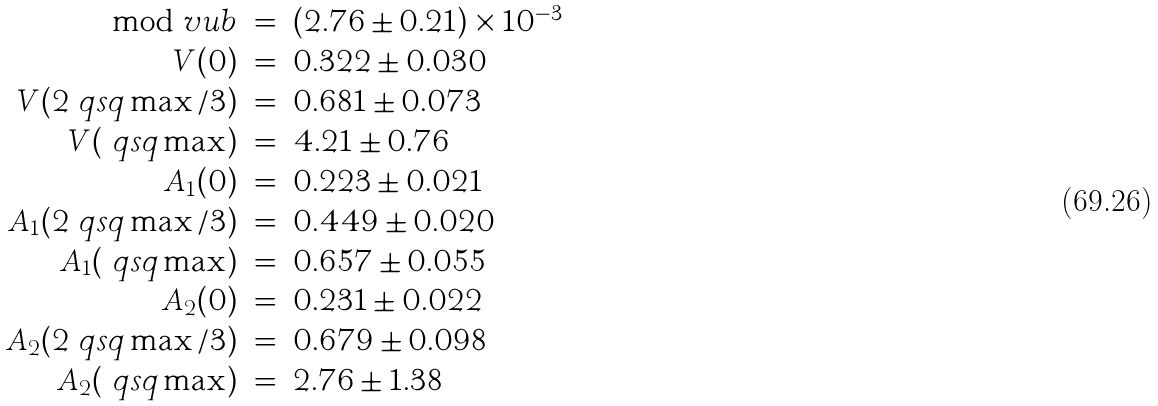<formula> <loc_0><loc_0><loc_500><loc_500>\begin{array} { r c l } \mod v u b & = & \left ( 2 . 7 6 \pm 0 . 2 1 \right ) \times 1 0 ^ { - 3 } \\ V ( 0 ) & = & 0 . 3 2 2 \pm 0 . 0 3 0 \\ V ( 2 \ q s q \max / 3 ) & = & 0 . 6 8 1 \pm 0 . 0 7 3 \\ V ( \ q s q \max ) & = & 4 . 2 1 \pm 0 . 7 6 \\ A _ { 1 } ( 0 ) & = & 0 . 2 2 3 \pm 0 . 0 2 1 \\ A _ { 1 } ( 2 \ q s q \max / 3 ) & = & 0 . 4 4 9 \pm 0 . 0 2 0 \\ A _ { 1 } ( \ q s q \max ) & = & 0 . 6 5 7 \pm 0 . 0 5 5 \\ A _ { 2 } ( 0 ) & = & 0 . 2 3 1 \pm 0 . 0 2 2 \\ A _ { 2 } ( 2 \ q s q \max / 3 ) & = & 0 . 6 7 9 \pm 0 . 0 9 8 \\ A _ { 2 } ( \ q s q \max ) & = & 2 . 7 6 \pm 1 . 3 8 \\ \end{array}</formula> 